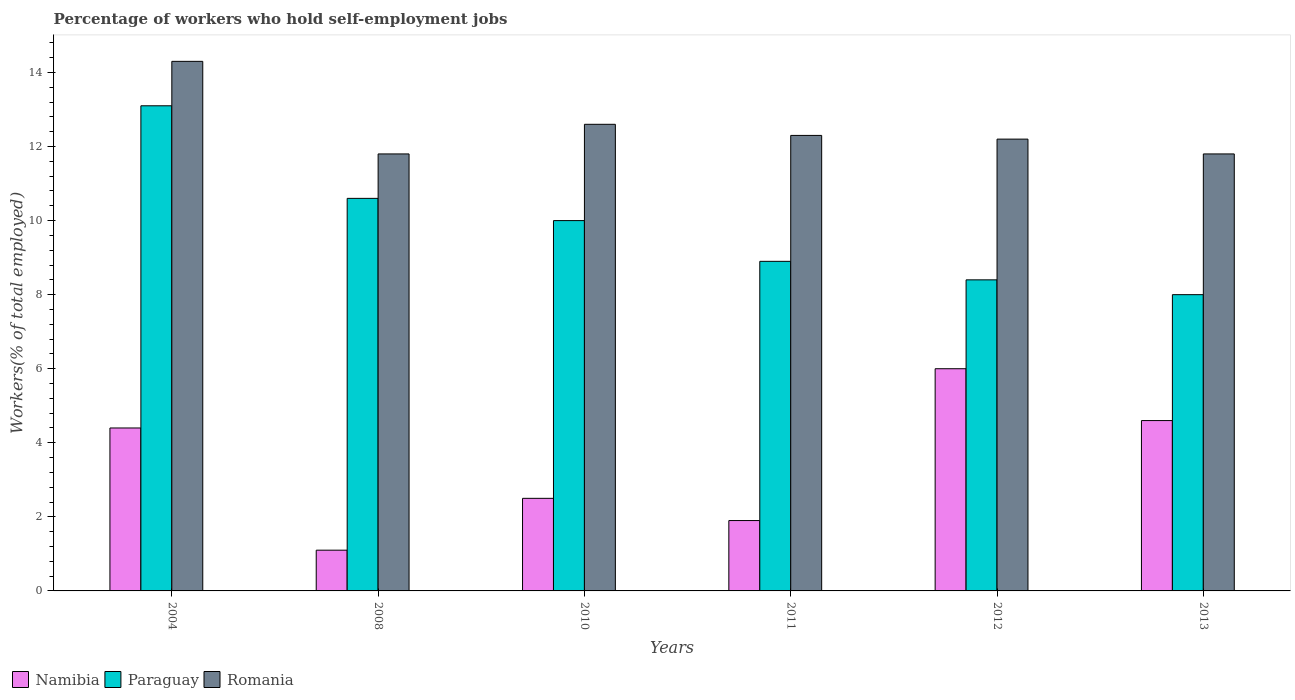How many different coloured bars are there?
Your answer should be very brief. 3. Are the number of bars per tick equal to the number of legend labels?
Your answer should be very brief. Yes. Are the number of bars on each tick of the X-axis equal?
Your answer should be very brief. Yes. How many bars are there on the 3rd tick from the left?
Ensure brevity in your answer.  3. How many bars are there on the 2nd tick from the right?
Ensure brevity in your answer.  3. In how many cases, is the number of bars for a given year not equal to the number of legend labels?
Your response must be concise. 0. What is the percentage of self-employed workers in Paraguay in 2004?
Your answer should be compact. 13.1. Across all years, what is the maximum percentage of self-employed workers in Paraguay?
Your response must be concise. 13.1. Across all years, what is the minimum percentage of self-employed workers in Romania?
Offer a very short reply. 11.8. In which year was the percentage of self-employed workers in Paraguay minimum?
Give a very brief answer. 2013. What is the total percentage of self-employed workers in Romania in the graph?
Your answer should be very brief. 75. What is the difference between the percentage of self-employed workers in Romania in 2012 and that in 2013?
Make the answer very short. 0.4. What is the difference between the percentage of self-employed workers in Paraguay in 2008 and the percentage of self-employed workers in Namibia in 2013?
Provide a succinct answer. 6. What is the average percentage of self-employed workers in Romania per year?
Provide a short and direct response. 12.5. In the year 2012, what is the difference between the percentage of self-employed workers in Namibia and percentage of self-employed workers in Paraguay?
Provide a succinct answer. -2.4. What is the ratio of the percentage of self-employed workers in Romania in 2004 to that in 2013?
Offer a very short reply. 1.21. Is the percentage of self-employed workers in Namibia in 2004 less than that in 2008?
Offer a very short reply. No. What is the difference between the highest and the second highest percentage of self-employed workers in Romania?
Your answer should be very brief. 1.7. What is the difference between the highest and the lowest percentage of self-employed workers in Paraguay?
Offer a very short reply. 5.1. In how many years, is the percentage of self-employed workers in Namibia greater than the average percentage of self-employed workers in Namibia taken over all years?
Your answer should be compact. 3. What does the 1st bar from the left in 2010 represents?
Your answer should be compact. Namibia. What does the 1st bar from the right in 2011 represents?
Provide a succinct answer. Romania. Are all the bars in the graph horizontal?
Provide a succinct answer. No. How many years are there in the graph?
Make the answer very short. 6. Does the graph contain grids?
Ensure brevity in your answer.  No. Where does the legend appear in the graph?
Your answer should be very brief. Bottom left. How many legend labels are there?
Provide a short and direct response. 3. How are the legend labels stacked?
Give a very brief answer. Horizontal. What is the title of the graph?
Offer a terse response. Percentage of workers who hold self-employment jobs. What is the label or title of the Y-axis?
Make the answer very short. Workers(% of total employed). What is the Workers(% of total employed) in Namibia in 2004?
Your answer should be very brief. 4.4. What is the Workers(% of total employed) in Paraguay in 2004?
Your answer should be very brief. 13.1. What is the Workers(% of total employed) in Romania in 2004?
Your answer should be very brief. 14.3. What is the Workers(% of total employed) of Namibia in 2008?
Your answer should be very brief. 1.1. What is the Workers(% of total employed) of Paraguay in 2008?
Make the answer very short. 10.6. What is the Workers(% of total employed) in Romania in 2008?
Provide a succinct answer. 11.8. What is the Workers(% of total employed) of Romania in 2010?
Your answer should be compact. 12.6. What is the Workers(% of total employed) of Namibia in 2011?
Provide a succinct answer. 1.9. What is the Workers(% of total employed) in Paraguay in 2011?
Offer a very short reply. 8.9. What is the Workers(% of total employed) of Romania in 2011?
Provide a short and direct response. 12.3. What is the Workers(% of total employed) in Paraguay in 2012?
Offer a terse response. 8.4. What is the Workers(% of total employed) in Romania in 2012?
Provide a short and direct response. 12.2. What is the Workers(% of total employed) of Namibia in 2013?
Provide a succinct answer. 4.6. What is the Workers(% of total employed) in Romania in 2013?
Your response must be concise. 11.8. Across all years, what is the maximum Workers(% of total employed) in Namibia?
Your answer should be very brief. 6. Across all years, what is the maximum Workers(% of total employed) in Paraguay?
Provide a succinct answer. 13.1. Across all years, what is the maximum Workers(% of total employed) of Romania?
Your response must be concise. 14.3. Across all years, what is the minimum Workers(% of total employed) in Namibia?
Provide a succinct answer. 1.1. Across all years, what is the minimum Workers(% of total employed) in Romania?
Make the answer very short. 11.8. What is the difference between the Workers(% of total employed) in Namibia in 2004 and that in 2008?
Provide a short and direct response. 3.3. What is the difference between the Workers(% of total employed) in Paraguay in 2004 and that in 2011?
Keep it short and to the point. 4.2. What is the difference between the Workers(% of total employed) of Romania in 2004 and that in 2011?
Provide a succinct answer. 2. What is the difference between the Workers(% of total employed) of Namibia in 2004 and that in 2012?
Offer a very short reply. -1.6. What is the difference between the Workers(% of total employed) in Paraguay in 2004 and that in 2012?
Offer a very short reply. 4.7. What is the difference between the Workers(% of total employed) of Romania in 2004 and that in 2012?
Offer a very short reply. 2.1. What is the difference between the Workers(% of total employed) in Namibia in 2004 and that in 2013?
Your response must be concise. -0.2. What is the difference between the Workers(% of total employed) of Paraguay in 2004 and that in 2013?
Your answer should be compact. 5.1. What is the difference between the Workers(% of total employed) of Romania in 2004 and that in 2013?
Ensure brevity in your answer.  2.5. What is the difference between the Workers(% of total employed) in Namibia in 2008 and that in 2010?
Your response must be concise. -1.4. What is the difference between the Workers(% of total employed) of Namibia in 2008 and that in 2011?
Provide a short and direct response. -0.8. What is the difference between the Workers(% of total employed) in Romania in 2008 and that in 2011?
Offer a very short reply. -0.5. What is the difference between the Workers(% of total employed) in Paraguay in 2008 and that in 2012?
Offer a very short reply. 2.2. What is the difference between the Workers(% of total employed) of Paraguay in 2008 and that in 2013?
Provide a succinct answer. 2.6. What is the difference between the Workers(% of total employed) in Romania in 2008 and that in 2013?
Keep it short and to the point. 0. What is the difference between the Workers(% of total employed) of Namibia in 2010 and that in 2012?
Offer a very short reply. -3.5. What is the difference between the Workers(% of total employed) of Paraguay in 2010 and that in 2013?
Offer a very short reply. 2. What is the difference between the Workers(% of total employed) of Romania in 2010 and that in 2013?
Your response must be concise. 0.8. What is the difference between the Workers(% of total employed) of Romania in 2011 and that in 2012?
Give a very brief answer. 0.1. What is the difference between the Workers(% of total employed) in Namibia in 2004 and the Workers(% of total employed) in Paraguay in 2008?
Your answer should be compact. -6.2. What is the difference between the Workers(% of total employed) of Paraguay in 2004 and the Workers(% of total employed) of Romania in 2008?
Give a very brief answer. 1.3. What is the difference between the Workers(% of total employed) of Namibia in 2004 and the Workers(% of total employed) of Paraguay in 2010?
Offer a very short reply. -5.6. What is the difference between the Workers(% of total employed) of Namibia in 2004 and the Workers(% of total employed) of Romania in 2010?
Provide a succinct answer. -8.2. What is the difference between the Workers(% of total employed) in Paraguay in 2004 and the Workers(% of total employed) in Romania in 2010?
Give a very brief answer. 0.5. What is the difference between the Workers(% of total employed) of Namibia in 2004 and the Workers(% of total employed) of Paraguay in 2011?
Your answer should be very brief. -4.5. What is the difference between the Workers(% of total employed) in Namibia in 2004 and the Workers(% of total employed) in Romania in 2011?
Provide a short and direct response. -7.9. What is the difference between the Workers(% of total employed) of Paraguay in 2004 and the Workers(% of total employed) of Romania in 2011?
Give a very brief answer. 0.8. What is the difference between the Workers(% of total employed) of Namibia in 2004 and the Workers(% of total employed) of Paraguay in 2012?
Make the answer very short. -4. What is the difference between the Workers(% of total employed) in Paraguay in 2004 and the Workers(% of total employed) in Romania in 2013?
Your answer should be compact. 1.3. What is the difference between the Workers(% of total employed) in Namibia in 2008 and the Workers(% of total employed) in Paraguay in 2010?
Provide a succinct answer. -8.9. What is the difference between the Workers(% of total employed) in Paraguay in 2008 and the Workers(% of total employed) in Romania in 2010?
Offer a terse response. -2. What is the difference between the Workers(% of total employed) in Namibia in 2008 and the Workers(% of total employed) in Romania in 2011?
Provide a short and direct response. -11.2. What is the difference between the Workers(% of total employed) in Paraguay in 2008 and the Workers(% of total employed) in Romania in 2011?
Your answer should be very brief. -1.7. What is the difference between the Workers(% of total employed) of Namibia in 2008 and the Workers(% of total employed) of Paraguay in 2012?
Provide a succinct answer. -7.3. What is the difference between the Workers(% of total employed) of Namibia in 2008 and the Workers(% of total employed) of Romania in 2013?
Make the answer very short. -10.7. What is the difference between the Workers(% of total employed) in Paraguay in 2008 and the Workers(% of total employed) in Romania in 2013?
Make the answer very short. -1.2. What is the difference between the Workers(% of total employed) of Namibia in 2010 and the Workers(% of total employed) of Paraguay in 2012?
Offer a very short reply. -5.9. What is the difference between the Workers(% of total employed) in Namibia in 2010 and the Workers(% of total employed) in Romania in 2012?
Your answer should be compact. -9.7. What is the difference between the Workers(% of total employed) of Paraguay in 2010 and the Workers(% of total employed) of Romania in 2013?
Keep it short and to the point. -1.8. What is the difference between the Workers(% of total employed) of Namibia in 2011 and the Workers(% of total employed) of Paraguay in 2012?
Your answer should be compact. -6.5. What is the difference between the Workers(% of total employed) of Namibia in 2011 and the Workers(% of total employed) of Romania in 2012?
Your response must be concise. -10.3. What is the difference between the Workers(% of total employed) of Paraguay in 2011 and the Workers(% of total employed) of Romania in 2012?
Offer a very short reply. -3.3. What is the difference between the Workers(% of total employed) in Paraguay in 2011 and the Workers(% of total employed) in Romania in 2013?
Provide a succinct answer. -2.9. What is the difference between the Workers(% of total employed) in Namibia in 2012 and the Workers(% of total employed) in Paraguay in 2013?
Your response must be concise. -2. What is the difference between the Workers(% of total employed) of Paraguay in 2012 and the Workers(% of total employed) of Romania in 2013?
Ensure brevity in your answer.  -3.4. What is the average Workers(% of total employed) in Namibia per year?
Offer a terse response. 3.42. What is the average Workers(% of total employed) in Paraguay per year?
Your answer should be compact. 9.83. What is the average Workers(% of total employed) in Romania per year?
Your answer should be compact. 12.5. In the year 2004, what is the difference between the Workers(% of total employed) in Namibia and Workers(% of total employed) in Paraguay?
Offer a very short reply. -8.7. In the year 2004, what is the difference between the Workers(% of total employed) in Namibia and Workers(% of total employed) in Romania?
Keep it short and to the point. -9.9. In the year 2008, what is the difference between the Workers(% of total employed) in Namibia and Workers(% of total employed) in Paraguay?
Keep it short and to the point. -9.5. In the year 2008, what is the difference between the Workers(% of total employed) of Paraguay and Workers(% of total employed) of Romania?
Offer a terse response. -1.2. In the year 2010, what is the difference between the Workers(% of total employed) in Namibia and Workers(% of total employed) in Paraguay?
Provide a succinct answer. -7.5. In the year 2010, what is the difference between the Workers(% of total employed) in Namibia and Workers(% of total employed) in Romania?
Provide a succinct answer. -10.1. In the year 2012, what is the difference between the Workers(% of total employed) in Namibia and Workers(% of total employed) in Paraguay?
Make the answer very short. -2.4. In the year 2012, what is the difference between the Workers(% of total employed) of Namibia and Workers(% of total employed) of Romania?
Offer a terse response. -6.2. In the year 2012, what is the difference between the Workers(% of total employed) in Paraguay and Workers(% of total employed) in Romania?
Keep it short and to the point. -3.8. In the year 2013, what is the difference between the Workers(% of total employed) of Namibia and Workers(% of total employed) of Paraguay?
Make the answer very short. -3.4. In the year 2013, what is the difference between the Workers(% of total employed) of Paraguay and Workers(% of total employed) of Romania?
Provide a short and direct response. -3.8. What is the ratio of the Workers(% of total employed) in Paraguay in 2004 to that in 2008?
Your answer should be compact. 1.24. What is the ratio of the Workers(% of total employed) of Romania in 2004 to that in 2008?
Provide a succinct answer. 1.21. What is the ratio of the Workers(% of total employed) in Namibia in 2004 to that in 2010?
Make the answer very short. 1.76. What is the ratio of the Workers(% of total employed) in Paraguay in 2004 to that in 2010?
Provide a short and direct response. 1.31. What is the ratio of the Workers(% of total employed) of Romania in 2004 to that in 2010?
Offer a terse response. 1.13. What is the ratio of the Workers(% of total employed) of Namibia in 2004 to that in 2011?
Offer a terse response. 2.32. What is the ratio of the Workers(% of total employed) in Paraguay in 2004 to that in 2011?
Your answer should be very brief. 1.47. What is the ratio of the Workers(% of total employed) in Romania in 2004 to that in 2011?
Keep it short and to the point. 1.16. What is the ratio of the Workers(% of total employed) of Namibia in 2004 to that in 2012?
Make the answer very short. 0.73. What is the ratio of the Workers(% of total employed) in Paraguay in 2004 to that in 2012?
Give a very brief answer. 1.56. What is the ratio of the Workers(% of total employed) of Romania in 2004 to that in 2012?
Offer a terse response. 1.17. What is the ratio of the Workers(% of total employed) of Namibia in 2004 to that in 2013?
Give a very brief answer. 0.96. What is the ratio of the Workers(% of total employed) of Paraguay in 2004 to that in 2013?
Give a very brief answer. 1.64. What is the ratio of the Workers(% of total employed) of Romania in 2004 to that in 2013?
Your response must be concise. 1.21. What is the ratio of the Workers(% of total employed) in Namibia in 2008 to that in 2010?
Offer a very short reply. 0.44. What is the ratio of the Workers(% of total employed) in Paraguay in 2008 to that in 2010?
Provide a succinct answer. 1.06. What is the ratio of the Workers(% of total employed) in Romania in 2008 to that in 2010?
Ensure brevity in your answer.  0.94. What is the ratio of the Workers(% of total employed) in Namibia in 2008 to that in 2011?
Offer a terse response. 0.58. What is the ratio of the Workers(% of total employed) in Paraguay in 2008 to that in 2011?
Offer a terse response. 1.19. What is the ratio of the Workers(% of total employed) of Romania in 2008 to that in 2011?
Offer a terse response. 0.96. What is the ratio of the Workers(% of total employed) in Namibia in 2008 to that in 2012?
Give a very brief answer. 0.18. What is the ratio of the Workers(% of total employed) of Paraguay in 2008 to that in 2012?
Provide a succinct answer. 1.26. What is the ratio of the Workers(% of total employed) in Romania in 2008 to that in 2012?
Provide a succinct answer. 0.97. What is the ratio of the Workers(% of total employed) in Namibia in 2008 to that in 2013?
Your answer should be very brief. 0.24. What is the ratio of the Workers(% of total employed) of Paraguay in 2008 to that in 2013?
Make the answer very short. 1.32. What is the ratio of the Workers(% of total employed) in Namibia in 2010 to that in 2011?
Keep it short and to the point. 1.32. What is the ratio of the Workers(% of total employed) of Paraguay in 2010 to that in 2011?
Your answer should be very brief. 1.12. What is the ratio of the Workers(% of total employed) of Romania in 2010 to that in 2011?
Offer a very short reply. 1.02. What is the ratio of the Workers(% of total employed) of Namibia in 2010 to that in 2012?
Provide a succinct answer. 0.42. What is the ratio of the Workers(% of total employed) in Paraguay in 2010 to that in 2012?
Keep it short and to the point. 1.19. What is the ratio of the Workers(% of total employed) in Romania in 2010 to that in 2012?
Offer a terse response. 1.03. What is the ratio of the Workers(% of total employed) of Namibia in 2010 to that in 2013?
Provide a short and direct response. 0.54. What is the ratio of the Workers(% of total employed) of Romania in 2010 to that in 2013?
Offer a very short reply. 1.07. What is the ratio of the Workers(% of total employed) of Namibia in 2011 to that in 2012?
Your answer should be compact. 0.32. What is the ratio of the Workers(% of total employed) of Paraguay in 2011 to that in 2012?
Offer a very short reply. 1.06. What is the ratio of the Workers(% of total employed) of Romania in 2011 to that in 2012?
Provide a short and direct response. 1.01. What is the ratio of the Workers(% of total employed) in Namibia in 2011 to that in 2013?
Make the answer very short. 0.41. What is the ratio of the Workers(% of total employed) of Paraguay in 2011 to that in 2013?
Offer a very short reply. 1.11. What is the ratio of the Workers(% of total employed) of Romania in 2011 to that in 2013?
Keep it short and to the point. 1.04. What is the ratio of the Workers(% of total employed) of Namibia in 2012 to that in 2013?
Provide a succinct answer. 1.3. What is the ratio of the Workers(% of total employed) in Paraguay in 2012 to that in 2013?
Your response must be concise. 1.05. What is the ratio of the Workers(% of total employed) of Romania in 2012 to that in 2013?
Give a very brief answer. 1.03. What is the difference between the highest and the second highest Workers(% of total employed) of Romania?
Your answer should be very brief. 1.7. What is the difference between the highest and the lowest Workers(% of total employed) in Namibia?
Your response must be concise. 4.9. What is the difference between the highest and the lowest Workers(% of total employed) of Paraguay?
Provide a short and direct response. 5.1. 